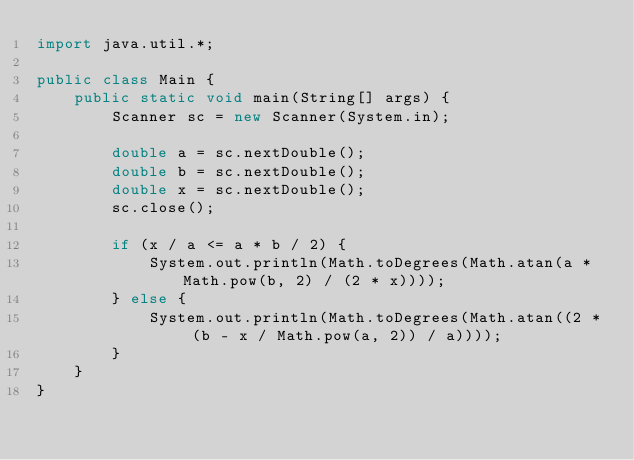Convert code to text. <code><loc_0><loc_0><loc_500><loc_500><_Java_>import java.util.*;

public class Main {
    public static void main(String[] args) {
        Scanner sc = new Scanner(System.in);

        double a = sc.nextDouble();
        double b = sc.nextDouble();
        double x = sc.nextDouble();
        sc.close();

        if (x / a <= a * b / 2) {
            System.out.println(Math.toDegrees(Math.atan(a * Math.pow(b, 2) / (2 * x))));
        } else {
            System.out.println(Math.toDegrees(Math.atan((2 * (b - x / Math.pow(a, 2)) / a))));
        }
    }
}</code> 